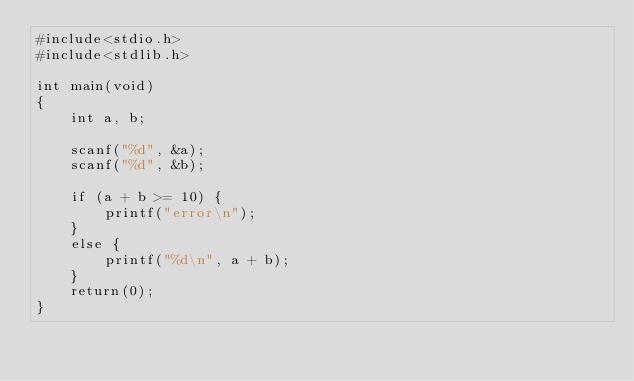<code> <loc_0><loc_0><loc_500><loc_500><_C_>#include<stdio.h>
#include<stdlib.h>

int main(void)
{
	int a, b;
	
	scanf("%d", &a);
	scanf("%d", &b);

	if (a + b >= 10) {
		printf("error\n");
	}
	else {
		printf("%d\n", a + b);
	}
	return(0);
}</code> 